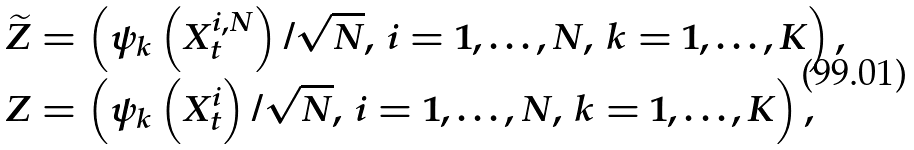Convert formula to latex. <formula><loc_0><loc_0><loc_500><loc_500>\widetilde { Z } & = \left ( \psi _ { k } \left ( X _ { t } ^ { i , N } \right ) / \sqrt { N } , \, i = 1 , \dots , N , \, k = 1 , \dots , K \right ) , \\ Z & = \left ( \psi _ { k } \left ( X _ { t } ^ { i } \right ) / \sqrt { N } , \, i = 1 , \dots , N , \, k = 1 , \dots , K \right ) ,</formula> 